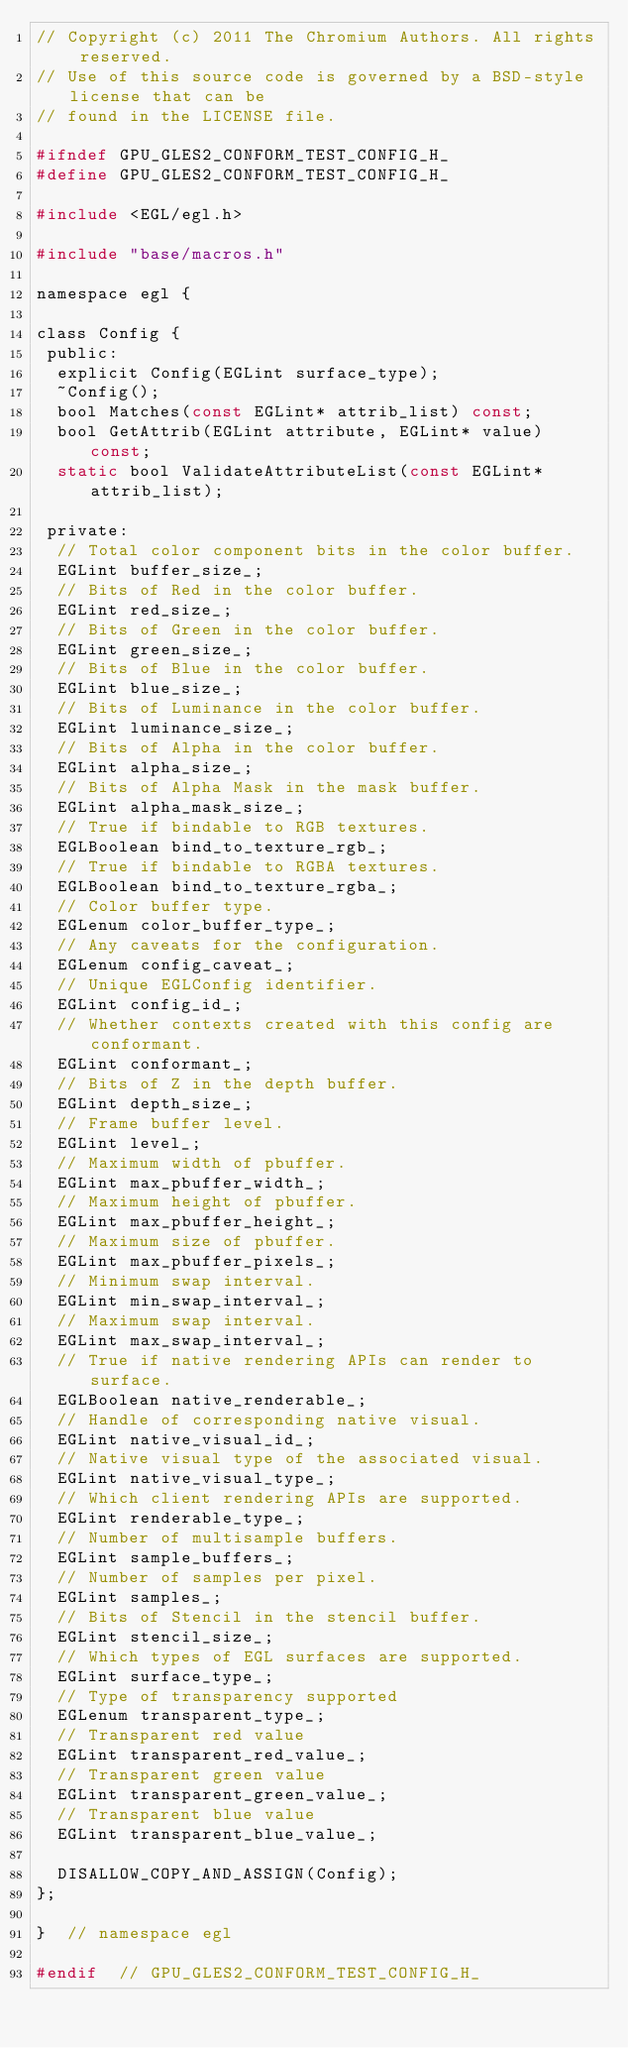<code> <loc_0><loc_0><loc_500><loc_500><_C_>// Copyright (c) 2011 The Chromium Authors. All rights reserved.
// Use of this source code is governed by a BSD-style license that can be
// found in the LICENSE file.

#ifndef GPU_GLES2_CONFORM_TEST_CONFIG_H_
#define GPU_GLES2_CONFORM_TEST_CONFIG_H_

#include <EGL/egl.h>

#include "base/macros.h"

namespace egl {

class Config {
 public:
  explicit Config(EGLint surface_type);
  ~Config();
  bool Matches(const EGLint* attrib_list) const;
  bool GetAttrib(EGLint attribute, EGLint* value) const;
  static bool ValidateAttributeList(const EGLint* attrib_list);

 private:
  // Total color component bits in the color buffer.
  EGLint buffer_size_;
  // Bits of Red in the color buffer.
  EGLint red_size_;
  // Bits of Green in the color buffer.
  EGLint green_size_;
  // Bits of Blue in the color buffer.
  EGLint blue_size_;
  // Bits of Luminance in the color buffer.
  EGLint luminance_size_;
  // Bits of Alpha in the color buffer.
  EGLint alpha_size_;
  // Bits of Alpha Mask in the mask buffer.
  EGLint alpha_mask_size_;
  // True if bindable to RGB textures.
  EGLBoolean bind_to_texture_rgb_;
  // True if bindable to RGBA textures.
  EGLBoolean bind_to_texture_rgba_;
  // Color buffer type.
  EGLenum color_buffer_type_;
  // Any caveats for the configuration.
  EGLenum config_caveat_;
  // Unique EGLConfig identifier.
  EGLint config_id_;
  // Whether contexts created with this config are conformant.
  EGLint conformant_;
  // Bits of Z in the depth buffer.
  EGLint depth_size_;
  // Frame buffer level.
  EGLint level_;
  // Maximum width of pbuffer.
  EGLint max_pbuffer_width_;
  // Maximum height of pbuffer.
  EGLint max_pbuffer_height_;
  // Maximum size of pbuffer.
  EGLint max_pbuffer_pixels_;
  // Minimum swap interval.
  EGLint min_swap_interval_;
  // Maximum swap interval.
  EGLint max_swap_interval_;
  // True if native rendering APIs can render to surface.
  EGLBoolean native_renderable_;
  // Handle of corresponding native visual.
  EGLint native_visual_id_;
  // Native visual type of the associated visual.
  EGLint native_visual_type_;
  // Which client rendering APIs are supported.
  EGLint renderable_type_;
  // Number of multisample buffers.
  EGLint sample_buffers_;
  // Number of samples per pixel.
  EGLint samples_;
  // Bits of Stencil in the stencil buffer.
  EGLint stencil_size_;
  // Which types of EGL surfaces are supported.
  EGLint surface_type_;
  // Type of transparency supported
  EGLenum transparent_type_;
  // Transparent red value
  EGLint transparent_red_value_;
  // Transparent green value
  EGLint transparent_green_value_;
  // Transparent blue value
  EGLint transparent_blue_value_;

  DISALLOW_COPY_AND_ASSIGN(Config);
};

}  // namespace egl

#endif  // GPU_GLES2_CONFORM_TEST_CONFIG_H_
</code> 